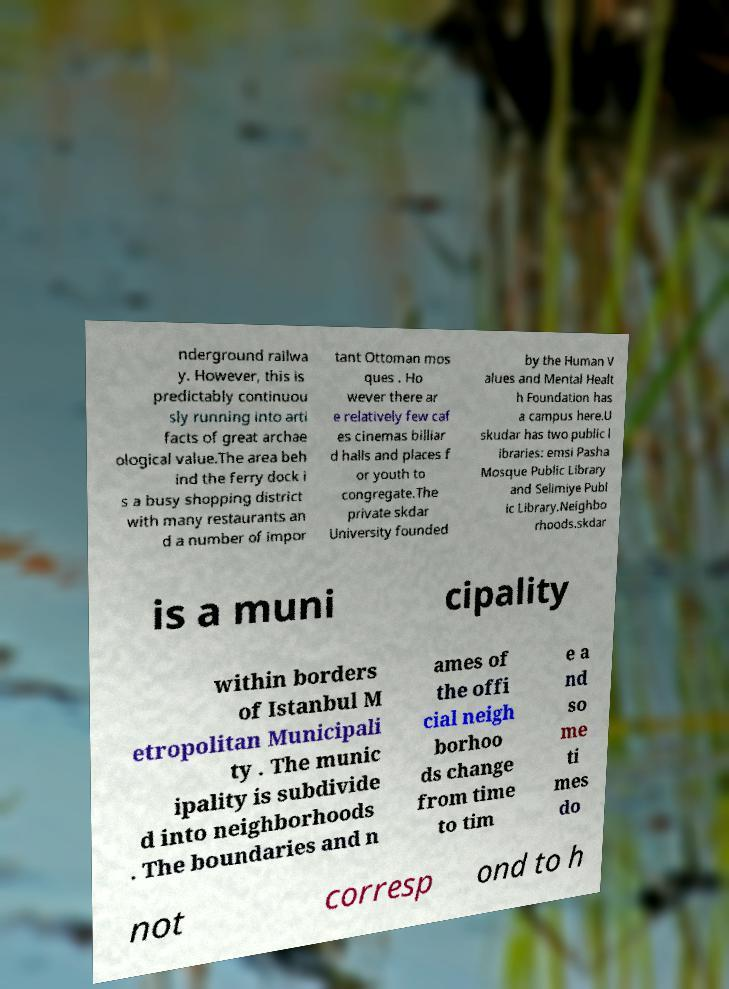Could you assist in decoding the text presented in this image and type it out clearly? nderground railwa y. However, this is predictably continuou sly running into arti facts of great archae ological value.The area beh ind the ferry dock i s a busy shopping district with many restaurants an d a number of impor tant Ottoman mos ques . Ho wever there ar e relatively few caf es cinemas billiar d halls and places f or youth to congregate.The private skdar University founded by the Human V alues and Mental Healt h Foundation has a campus here.U skudar has two public l ibraries: emsi Pasha Mosque Public Library and Selimiye Publ ic Library.Neighbo rhoods.skdar is a muni cipality within borders of Istanbul M etropolitan Municipali ty . The munic ipality is subdivide d into neighborhoods . The boundaries and n ames of the offi cial neigh borhoo ds change from time to tim e a nd so me ti mes do not corresp ond to h 